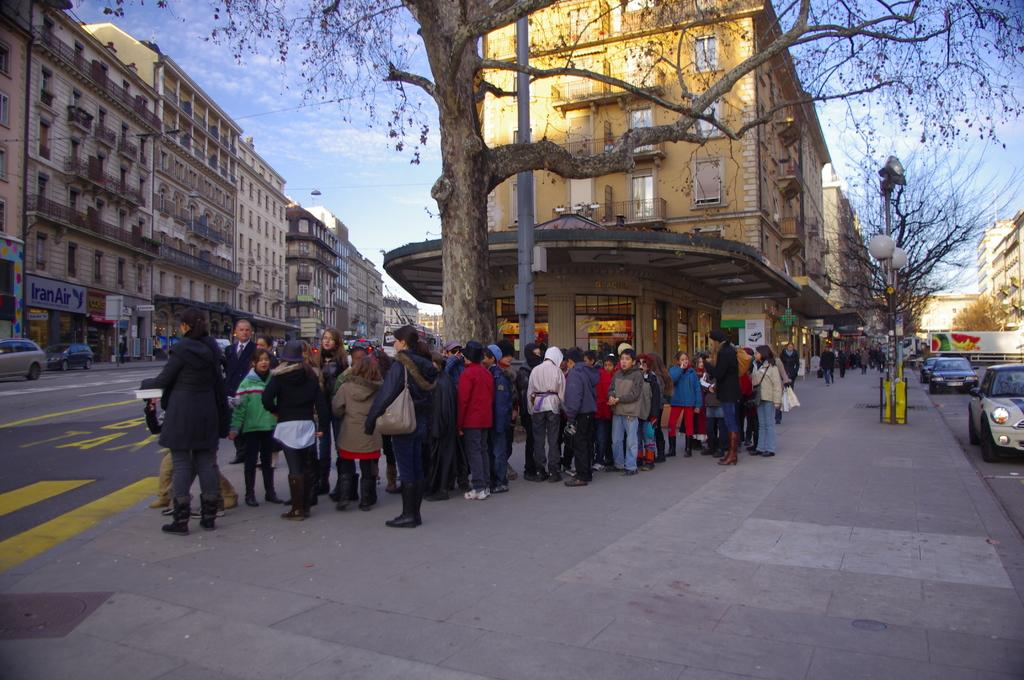What is happening on the road in the image? There are many people on the road, and vehicles are moving on the road. What can be seen in the background of the image? There are buildings in the background. Are there any natural elements visible in the image? Yes, there are trees visible. How would you describe the weather based on the image? The sky is cloudy in the image. Can you see any feathers floating in the air in the image? There are no feathers visible in the image. Is there a railway track present in the image? There is no railway track visible in the image. 